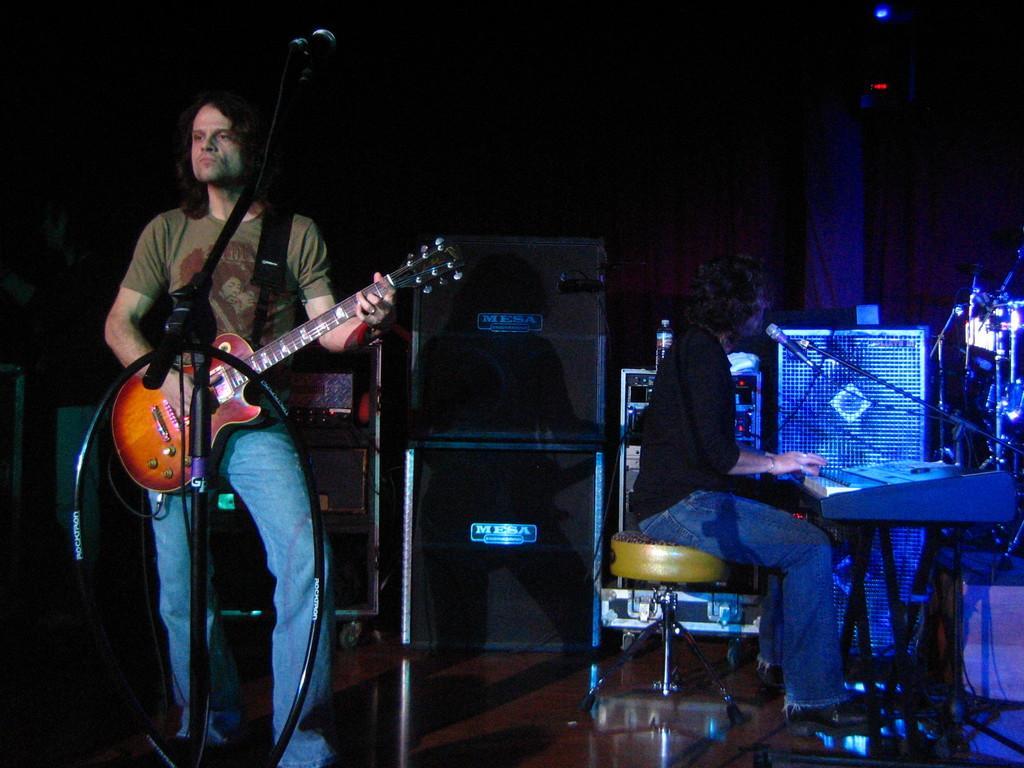In one or two sentences, can you explain what this image depicts? This picture describes about group of people, in the left side of the given image a man is playing guitar in front of microphone, and in the right side of the given image a woman is seated on the chair and playing keyboard. 